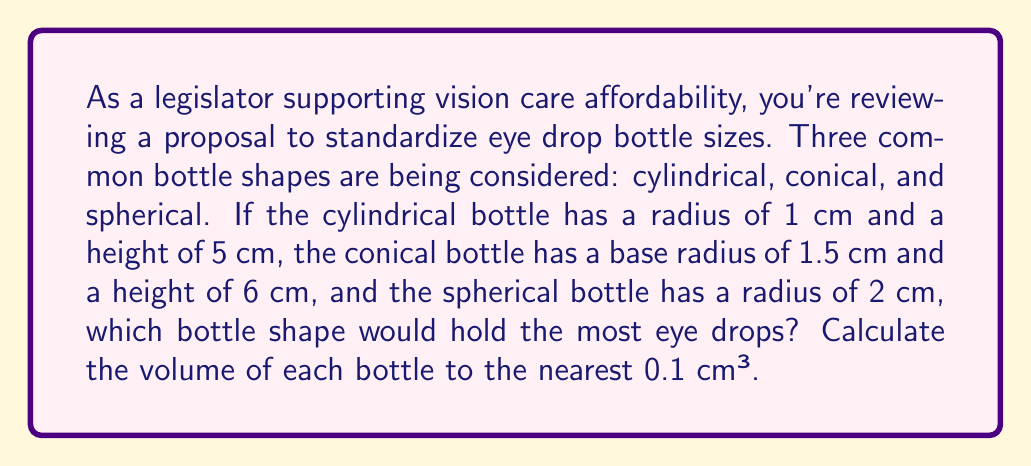Provide a solution to this math problem. To solve this problem, we need to calculate the volume of each bottle shape using the appropriate formulas:

1. Cylindrical bottle:
   Volume of a cylinder: $V = \pi r^2 h$
   $V_{cylinder} = \pi (1 \text{ cm})^2 (5 \text{ cm}) = 5\pi \approx 15.7 \text{ cm}^3$

2. Conical bottle:
   Volume of a cone: $V = \frac{1}{3}\pi r^2 h$
   $V_{cone} = \frac{1}{3}\pi (1.5 \text{ cm})^2 (6 \text{ cm}) = 4.5\pi \approx 14.1 \text{ cm}^3$

3. Spherical bottle:
   Volume of a sphere: $V = \frac{4}{3}\pi r^3$
   $V_{sphere} = \frac{4}{3}\pi (2 \text{ cm})^3 = \frac{32}{3}\pi \approx 33.5 \text{ cm}^3$

Comparing the volumes:
$V_{sphere} > V_{cylinder} > V_{cone}$

Therefore, the spherical bottle would hold the most eye drops.

[asy]
import geometry;

size(200);

draw(circle((0,0),2));
draw((0,-2)--(0,2));
draw((-2,0)--(2,0));
label("Sphere", (0,-2.5), S);

draw((5,-2)--(5,3)--(7,3)--(7,-2)--cycle);
label("Cylinder", (6,-2.5), S);

draw((11,-2)--(12.5,4)--(14,-2)--cycle);
label("Cone", (12.5,-2.5), S);
[/asy]
Answer: The spherical bottle would hold the most eye drops, with a volume of approximately 33.5 cm³. The cylindrical bottle would hold about 15.7 cm³, and the conical bottle would hold about 14.1 cm³. 